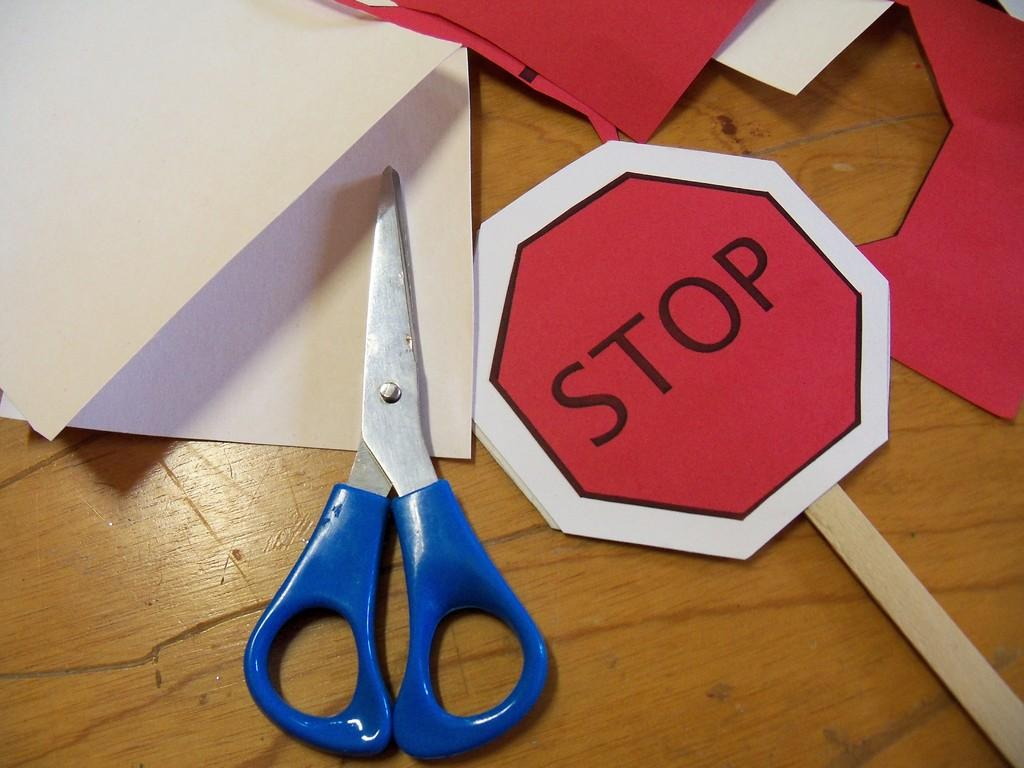<image>
Relay a brief, clear account of the picture shown. An art project where they made a Stop sign. 